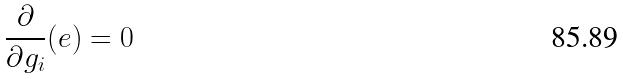Convert formula to latex. <formula><loc_0><loc_0><loc_500><loc_500>\frac { \partial } { \partial g _ { i } } ( e ) = 0</formula> 